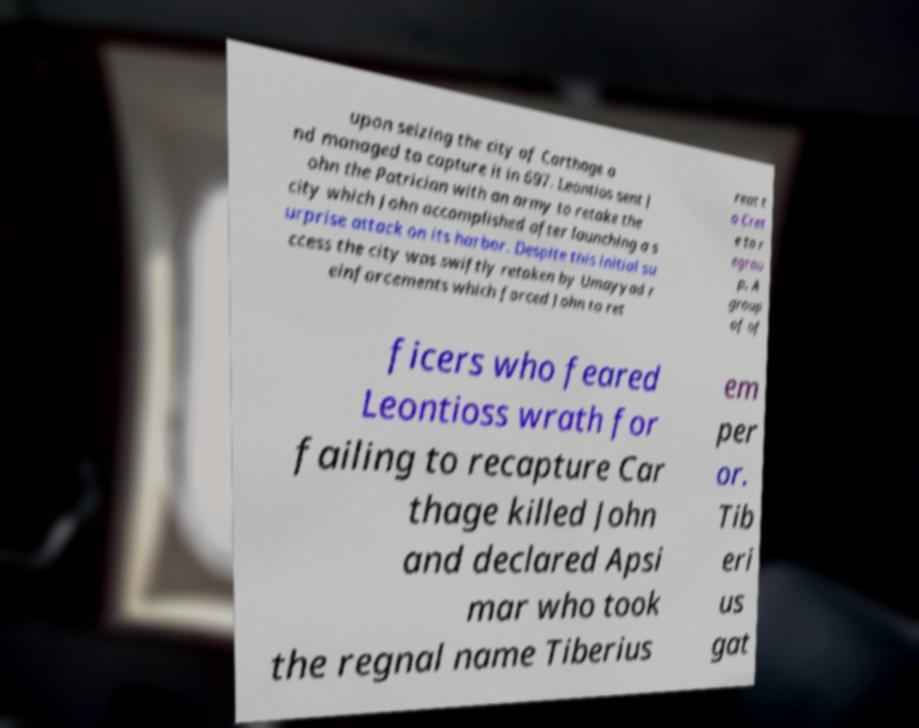Please identify and transcribe the text found in this image. upon seizing the city of Carthage a nd managed to capture it in 697. Leontios sent J ohn the Patrician with an army to retake the city which John accomplished after launching a s urprise attack on its harbor. Despite this initial su ccess the city was swiftly retaken by Umayyad r einforcements which forced John to ret reat t o Cret e to r egrou p. A group of of ficers who feared Leontioss wrath for failing to recapture Car thage killed John and declared Apsi mar who took the regnal name Tiberius em per or. Tib eri us gat 